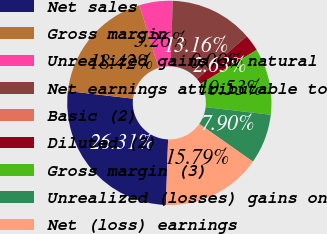Convert chart. <chart><loc_0><loc_0><loc_500><loc_500><pie_chart><fcel>Net sales<fcel>Gross margin<fcel>Unrealized gains on natural<fcel>Net earnings attributable to<fcel>Basic (2)<fcel>Diluted (2)<fcel>Gross margin (3)<fcel>Unrealized (losses) gains on<fcel>Net (loss) earnings<nl><fcel>26.31%<fcel>18.42%<fcel>5.26%<fcel>13.16%<fcel>0.0%<fcel>2.63%<fcel>10.53%<fcel>7.9%<fcel>15.79%<nl></chart> 